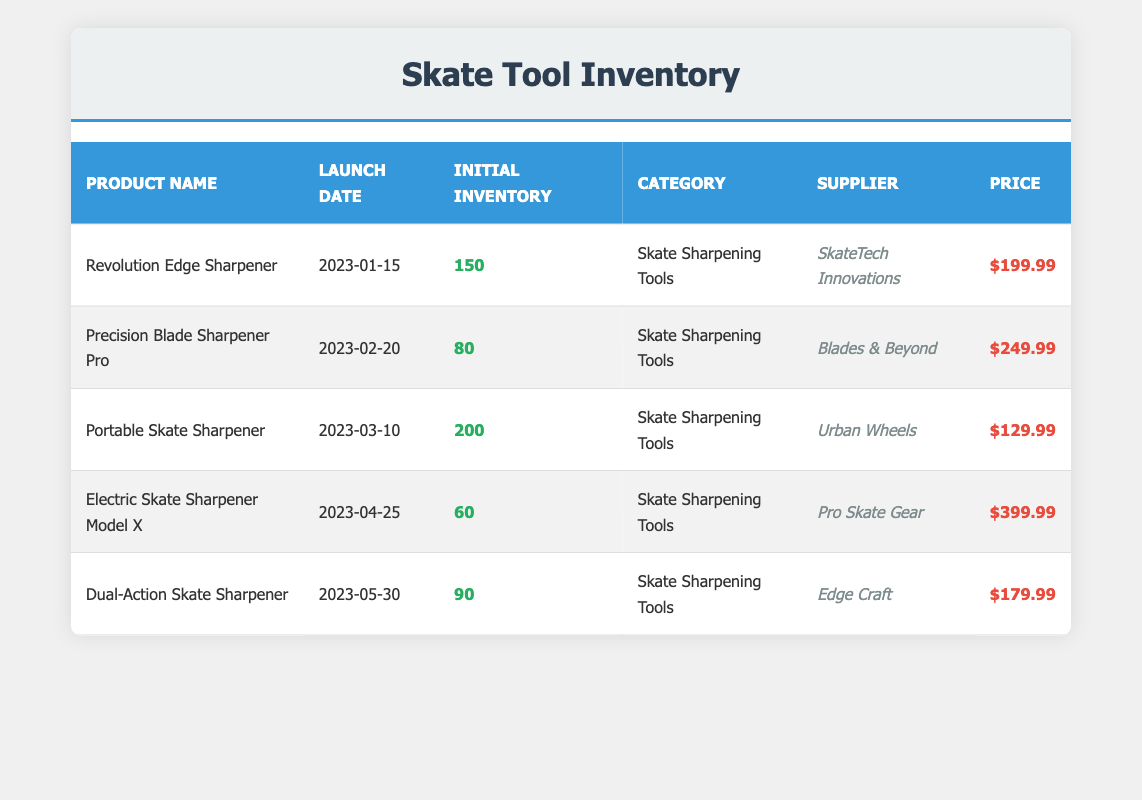What is the initial inventory count of the Revolution Edge Sharpener? The specific row for the Revolution Edge Sharpener lists its initial inventory count directly, which is 150.
Answer: 150 Which product has the lowest initial inventory count? The table shows initial inventory counts for all products, and by comparing, the Electric Skate Sharpener Model X has the lowest count of 60.
Answer: Electric Skate Sharpener Model X What is the average initial inventory count of all the products listed? Add up the initial inventory counts: 150 + 80 + 200 + 60 + 90 = 580. There are 5 products, so divide by 5: 580/5 = 116.
Answer: 116 Are all products categorized under Skate Sharpening Tools? Each product listed in the table has the category "Skate Sharpening Tools" consistently across all rows, confirming them all belong to this category.
Answer: Yes What is the total initial inventory count for sharpeners launched after March 2023? The relevant products launched after March 2023 are the Electric Skate Sharpener Model X and Dual-Action Skate Sharpener. Their counts are 60 and 90 respectively. Adding these gives 60 + 90 = 150.
Answer: 150 Which supplier offers the most expensive product? By examining the price for each product, the Electric Skate Sharpener Model X at $399.99 is the highest-priced item in the table.
Answer: Pro Skate Gear What is the price difference between the most expensive and least expensive products? The most expensive product is the Electric Skate Sharpener Model X at $399.99 and the least expensive is the Portable Skate Sharpener at $129.99. The price difference is calculated as $399.99 - $129.99 = $270.
Answer: 270 What percentage of the total initial inventory is accounted for by the Portable Skate Sharpener? First, calculate the total initial inventory which is 580. The Portable Skate Sharpener has an inventory of 200. To find the percentage: (200/580) * 100 = approximately 34.48%.
Answer: 34.48% Which products were launched between January and April 2023? The products launched in that timeline are the Revolution Edge Sharpener, Precision Blade Sharpener Pro, Portable Skate Sharpener, and Electric Skate Sharpener Model X. Their launch dates fit within that range.
Answer: Revolution Edge Sharpener, Precision Blade Sharpener Pro, Portable Skate Sharpener, Electric Skate Sharpener Model X 